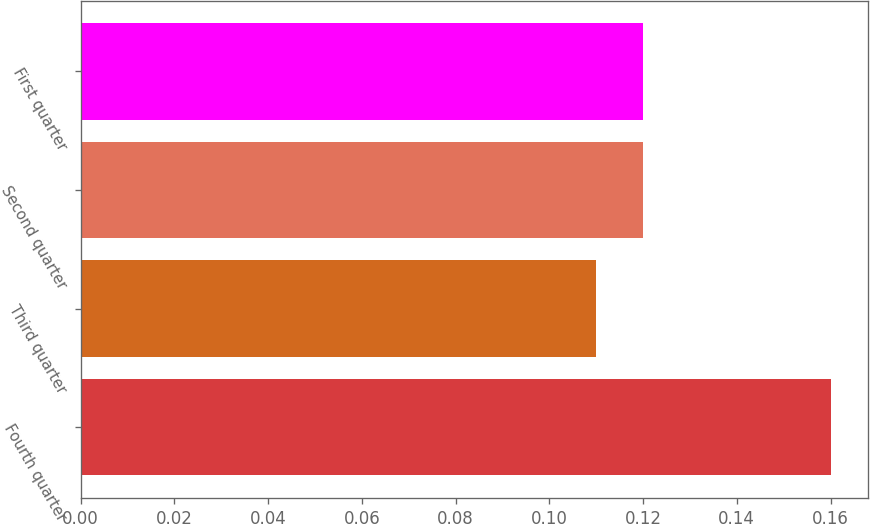Convert chart. <chart><loc_0><loc_0><loc_500><loc_500><bar_chart><fcel>Fourth quarter<fcel>Third quarter<fcel>Second quarter<fcel>First quarter<nl><fcel>0.16<fcel>0.11<fcel>0.12<fcel>0.12<nl></chart> 